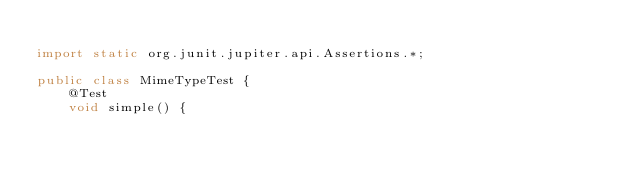<code> <loc_0><loc_0><loc_500><loc_500><_Java_>
import static org.junit.jupiter.api.Assertions.*;

public class MimeTypeTest {
    @Test
    void simple() {</code> 